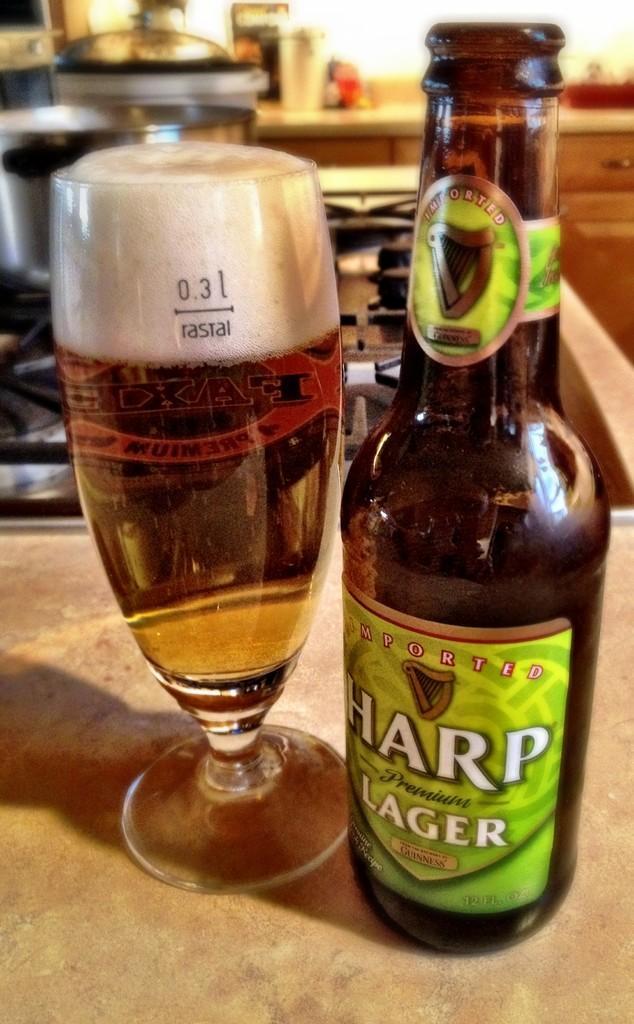Could you give a brief overview of what you see in this image? In this picture I can see there is a beer bottle and a beer glass placed here and the beer bottle has two labels and the glass is filled with beer and there is a stove in the backdrop and there are two utensils placed on the stove and the backdrop is blurred. 